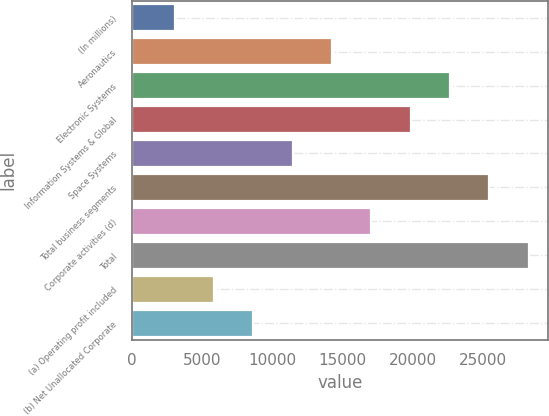Convert chart. <chart><loc_0><loc_0><loc_500><loc_500><bar_chart><fcel>(In millions)<fcel>Aeronautics<fcel>Electronic Systems<fcel>Information Systems & Global<fcel>Space Systems<fcel>Total business segments<fcel>Corporate activities (d)<fcel>Total<fcel>(a) Operating profit included<fcel>(b) Net Unallocated Corporate<nl><fcel>3030.1<fcel>14230.5<fcel>22630.8<fcel>19830.7<fcel>11430.4<fcel>25430.9<fcel>17030.6<fcel>28231<fcel>5830.2<fcel>8630.3<nl></chart> 